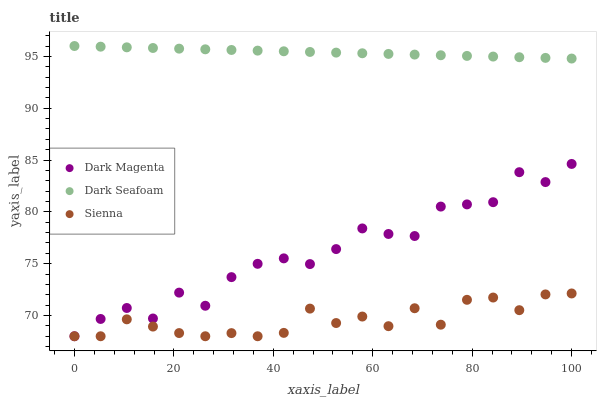Does Sienna have the minimum area under the curve?
Answer yes or no. Yes. Does Dark Seafoam have the maximum area under the curve?
Answer yes or no. Yes. Does Dark Magenta have the minimum area under the curve?
Answer yes or no. No. Does Dark Magenta have the maximum area under the curve?
Answer yes or no. No. Is Dark Seafoam the smoothest?
Answer yes or no. Yes. Is Dark Magenta the roughest?
Answer yes or no. Yes. Is Dark Magenta the smoothest?
Answer yes or no. No. Is Dark Seafoam the roughest?
Answer yes or no. No. Does Sienna have the lowest value?
Answer yes or no. Yes. Does Dark Seafoam have the lowest value?
Answer yes or no. No. Does Dark Seafoam have the highest value?
Answer yes or no. Yes. Does Dark Magenta have the highest value?
Answer yes or no. No. Is Dark Magenta less than Dark Seafoam?
Answer yes or no. Yes. Is Dark Seafoam greater than Dark Magenta?
Answer yes or no. Yes. Does Dark Magenta intersect Sienna?
Answer yes or no. Yes. Is Dark Magenta less than Sienna?
Answer yes or no. No. Is Dark Magenta greater than Sienna?
Answer yes or no. No. Does Dark Magenta intersect Dark Seafoam?
Answer yes or no. No. 